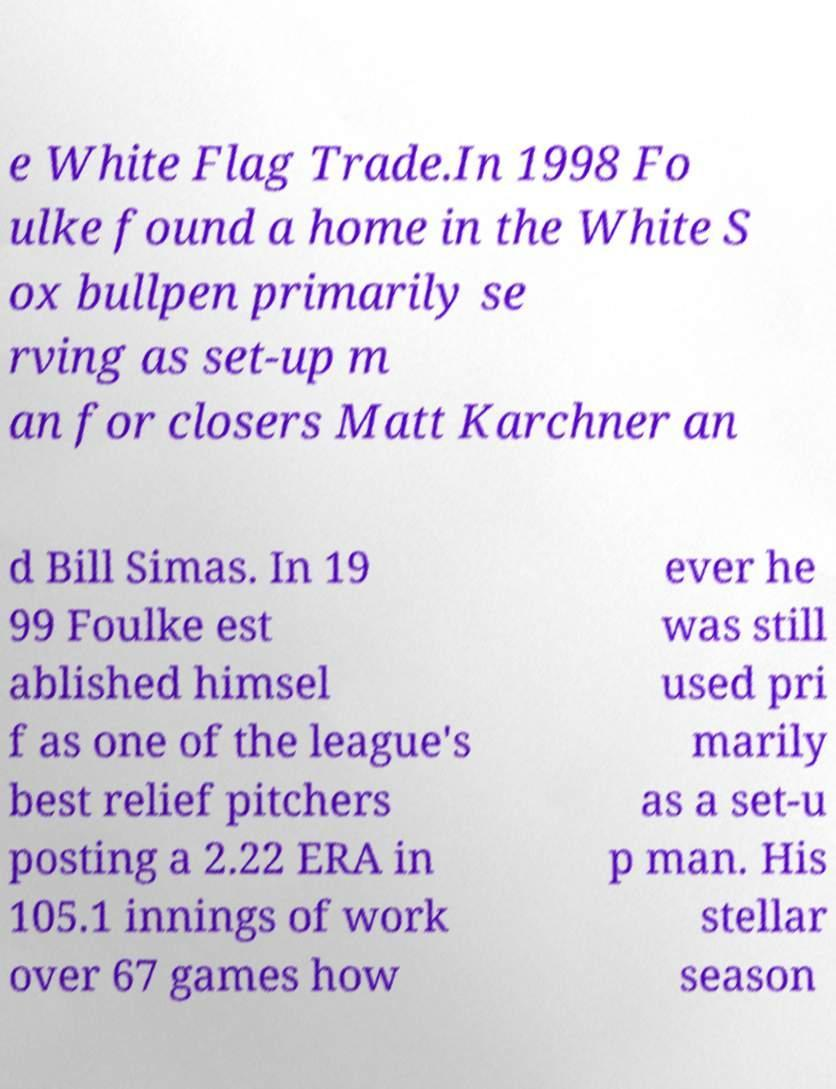Please identify and transcribe the text found in this image. e White Flag Trade.In 1998 Fo ulke found a home in the White S ox bullpen primarily se rving as set-up m an for closers Matt Karchner an d Bill Simas. In 19 99 Foulke est ablished himsel f as one of the league's best relief pitchers posting a 2.22 ERA in 105.1 innings of work over 67 games how ever he was still used pri marily as a set-u p man. His stellar season 